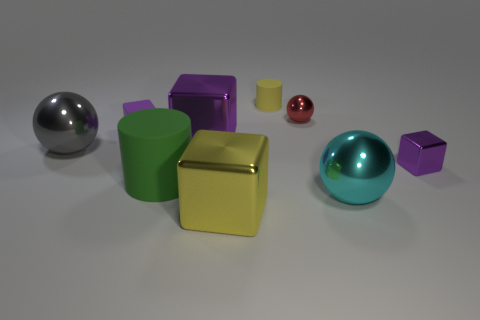How many purple cubes must be subtracted to get 1 purple cubes? 2 Subtract all purple spheres. How many purple blocks are left? 3 Add 1 large green metallic cylinders. How many objects exist? 10 Subtract all spheres. How many objects are left? 6 Add 5 large cyan spheres. How many large cyan spheres are left? 6 Add 6 rubber things. How many rubber things exist? 9 Subtract 1 cyan balls. How many objects are left? 8 Subtract all green matte things. Subtract all big shiny spheres. How many objects are left? 6 